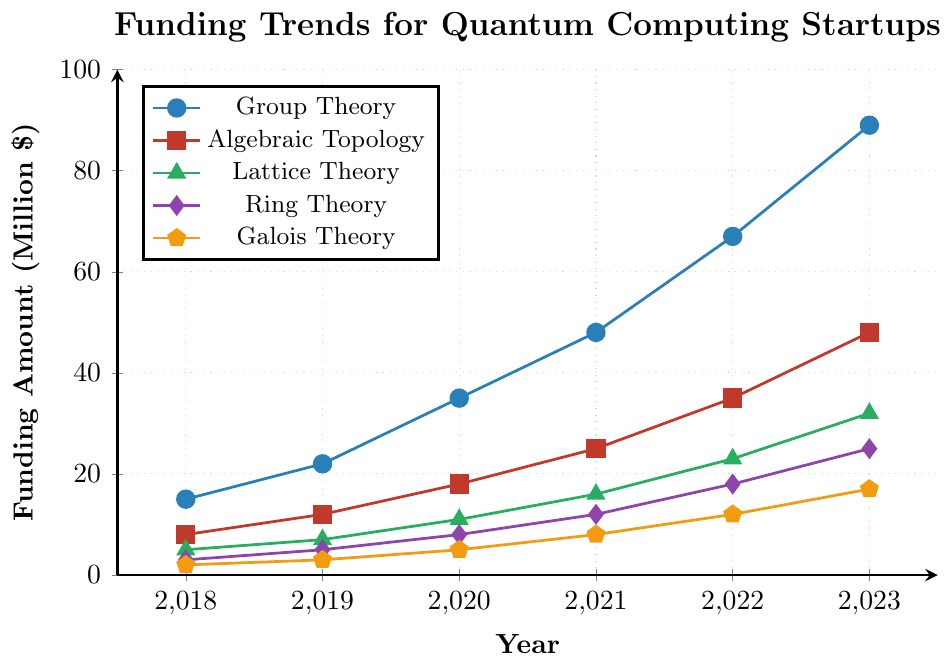What's the total funding amount across all subfields in 2023? To find the total funding in 2023, sum up the funding amounts for each subfield: 89 (Group Theory) + 48 (Algebraic Topology) + 32 (Lattice Theory) + 25 (Ring Theory) + 17 (Galois Theory). The calculations are: 89 + 48 + 32 + 25 + 17 = 211.
Answer: 211 Which subfield has shown the highest growth from 2018 to 2023? To determine the highest growth, subtract the 2018 values from the 2023 values for each subfield: Group Theory (89-15=74), Algebraic Topology (48-8=40), Lattice Theory (32-5=27), Ring Theory (25-3=22), Galois Theory (17-2=15). Group Theory shows the highest growth at 74 million USD.
Answer: Group Theory Over the period 2018-2023, which year did Ring Theory see the highest jump in funding compared to the previous year? Calculate the differences between consecutive years for Ring Theory: 2019-2018 (5-3=2), 2020-2019 (8-5=3), 2021-2020 (12-8=4), 2022-2021 (18-12=6), 2023-2022 (25-18=7). The highest jump is from 2022 to 2023 with a 7 million USD increase.
Answer: 2023 Compare the funding trends of Algebraic Topology and Lattice Theory in 2023. Which one has more funding and by how much? For 2023, Algebraic Topology has 48 million USD and Lattice Theory has 32 million USD. The difference is 48 - 32 = 16 million USD, with Algebraic Topology having more.
Answer: Algebraic Topology, 16 million USD Which subfield had the least amount of funding throughout all the years, and what was that amount in its first year? From the figure, Galois Theory consistently had the least funding in each year. Its funding amount in 2018 was 2 million USD.
Answer: Galois Theory, 2 What is the average funding for Lattice Theory over the 6 years? The funding for Lattice Theory over the years are: 5, 7, 11, 16, 23, 32. Sum these values (5+7+11+16+23+32) to get 94, then divide by 6: 94/6.
Answer: 15.67 million USD Which year did Algebraic Topology overtake Lattice Theory in funding? Comparing year-by-year, in 2018 and 2019 Algebraic Topology had values of 8 and 12 while Lattice Theory had 5 and 7. In 2020, Algebraic Topology's 18 overtakes Lattice Theory's 11.
Answer: 2020 Is the funding for Group Theory in 2022 less than the combined funding for Ring Theory and Galois Theory in 2023? Group Theory in 2022 is 67 million USD. Ring Theory and Galois Theory in 2023 sum to 25 + 17 = 42 million USD. Thus, 67 is not less than 42.
Answer: No Highlight the trend observed for funding in Algebraic Topology from 2018 to 2023. Algebraic Topology starts at 8 million USD in 2018 and consistently increases each year: 12 (2019), 18 (2020), 25 (2021), 35 (2022), 48 (2023). The trend shows a steady rise.
Answer: Steady increase Which subfield has doubled its funding at some point between 2018 and 2023, and in which year did this occur? Group Theory more than doubles from 2018 (15) to 2020 (35), Algebraic Topology more than doubles from 2018 (8) to 2020 (18), Lattice Theory from 2018 (5) to 2021 (16), Ring Theory from 2018 (3) to 2021 (12), and Galois Theory from 2018 (2) to 2021 (8).
Answer: Multiple subfields, different years 